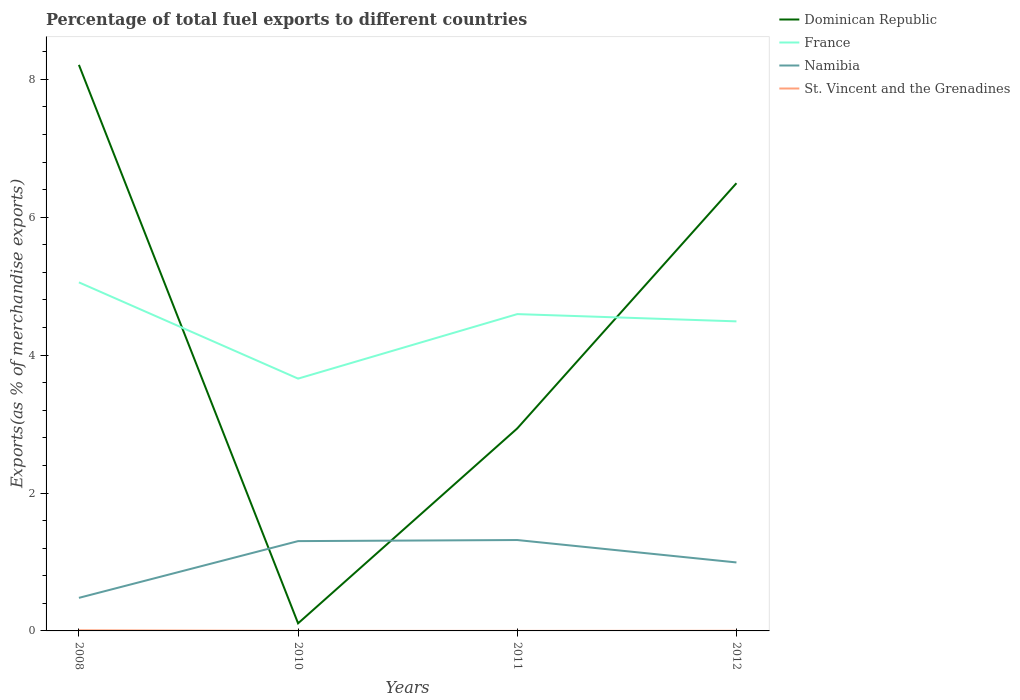Does the line corresponding to France intersect with the line corresponding to Dominican Republic?
Provide a succinct answer. Yes. Is the number of lines equal to the number of legend labels?
Your answer should be very brief. Yes. Across all years, what is the maximum percentage of exports to different countries in St. Vincent and the Grenadines?
Your answer should be very brief. 0. In which year was the percentage of exports to different countries in St. Vincent and the Grenadines maximum?
Offer a terse response. 2011. What is the total percentage of exports to different countries in St. Vincent and the Grenadines in the graph?
Offer a terse response. 0.01. What is the difference between the highest and the second highest percentage of exports to different countries in Namibia?
Give a very brief answer. 0.84. What is the difference between the highest and the lowest percentage of exports to different countries in Dominican Republic?
Your response must be concise. 2. How many lines are there?
Provide a succinct answer. 4. What is the difference between two consecutive major ticks on the Y-axis?
Your answer should be very brief. 2. Does the graph contain any zero values?
Provide a short and direct response. No. How many legend labels are there?
Give a very brief answer. 4. How are the legend labels stacked?
Provide a short and direct response. Vertical. What is the title of the graph?
Ensure brevity in your answer.  Percentage of total fuel exports to different countries. What is the label or title of the X-axis?
Keep it short and to the point. Years. What is the label or title of the Y-axis?
Make the answer very short. Exports(as % of merchandise exports). What is the Exports(as % of merchandise exports) of Dominican Republic in 2008?
Make the answer very short. 8.21. What is the Exports(as % of merchandise exports) in France in 2008?
Make the answer very short. 5.05. What is the Exports(as % of merchandise exports) in Namibia in 2008?
Your response must be concise. 0.48. What is the Exports(as % of merchandise exports) of St. Vincent and the Grenadines in 2008?
Make the answer very short. 0.01. What is the Exports(as % of merchandise exports) of Dominican Republic in 2010?
Your response must be concise. 0.11. What is the Exports(as % of merchandise exports) in France in 2010?
Offer a very short reply. 3.66. What is the Exports(as % of merchandise exports) in Namibia in 2010?
Make the answer very short. 1.3. What is the Exports(as % of merchandise exports) of St. Vincent and the Grenadines in 2010?
Give a very brief answer. 0. What is the Exports(as % of merchandise exports) of Dominican Republic in 2011?
Give a very brief answer. 2.94. What is the Exports(as % of merchandise exports) of France in 2011?
Provide a succinct answer. 4.59. What is the Exports(as % of merchandise exports) in Namibia in 2011?
Offer a terse response. 1.32. What is the Exports(as % of merchandise exports) of St. Vincent and the Grenadines in 2011?
Ensure brevity in your answer.  0. What is the Exports(as % of merchandise exports) of Dominican Republic in 2012?
Keep it short and to the point. 6.49. What is the Exports(as % of merchandise exports) of France in 2012?
Offer a very short reply. 4.49. What is the Exports(as % of merchandise exports) of Namibia in 2012?
Make the answer very short. 0.99. What is the Exports(as % of merchandise exports) in St. Vincent and the Grenadines in 2012?
Your answer should be compact. 0. Across all years, what is the maximum Exports(as % of merchandise exports) of Dominican Republic?
Offer a very short reply. 8.21. Across all years, what is the maximum Exports(as % of merchandise exports) in France?
Your response must be concise. 5.05. Across all years, what is the maximum Exports(as % of merchandise exports) in Namibia?
Provide a succinct answer. 1.32. Across all years, what is the maximum Exports(as % of merchandise exports) of St. Vincent and the Grenadines?
Your response must be concise. 0.01. Across all years, what is the minimum Exports(as % of merchandise exports) in Dominican Republic?
Your response must be concise. 0.11. Across all years, what is the minimum Exports(as % of merchandise exports) of France?
Your response must be concise. 3.66. Across all years, what is the minimum Exports(as % of merchandise exports) of Namibia?
Your answer should be compact. 0.48. Across all years, what is the minimum Exports(as % of merchandise exports) of St. Vincent and the Grenadines?
Your answer should be compact. 0. What is the total Exports(as % of merchandise exports) in Dominican Republic in the graph?
Ensure brevity in your answer.  17.75. What is the total Exports(as % of merchandise exports) of France in the graph?
Provide a short and direct response. 17.8. What is the total Exports(as % of merchandise exports) in Namibia in the graph?
Make the answer very short. 4.09. What is the total Exports(as % of merchandise exports) in St. Vincent and the Grenadines in the graph?
Provide a short and direct response. 0.01. What is the difference between the Exports(as % of merchandise exports) in Dominican Republic in 2008 and that in 2010?
Make the answer very short. 8.1. What is the difference between the Exports(as % of merchandise exports) in France in 2008 and that in 2010?
Give a very brief answer. 1.4. What is the difference between the Exports(as % of merchandise exports) of Namibia in 2008 and that in 2010?
Keep it short and to the point. -0.82. What is the difference between the Exports(as % of merchandise exports) in St. Vincent and the Grenadines in 2008 and that in 2010?
Ensure brevity in your answer.  0.01. What is the difference between the Exports(as % of merchandise exports) of Dominican Republic in 2008 and that in 2011?
Your answer should be compact. 5.27. What is the difference between the Exports(as % of merchandise exports) in France in 2008 and that in 2011?
Ensure brevity in your answer.  0.46. What is the difference between the Exports(as % of merchandise exports) in Namibia in 2008 and that in 2011?
Your answer should be compact. -0.84. What is the difference between the Exports(as % of merchandise exports) of St. Vincent and the Grenadines in 2008 and that in 2011?
Provide a succinct answer. 0.01. What is the difference between the Exports(as % of merchandise exports) of Dominican Republic in 2008 and that in 2012?
Your answer should be compact. 1.72. What is the difference between the Exports(as % of merchandise exports) in France in 2008 and that in 2012?
Ensure brevity in your answer.  0.57. What is the difference between the Exports(as % of merchandise exports) of Namibia in 2008 and that in 2012?
Give a very brief answer. -0.51. What is the difference between the Exports(as % of merchandise exports) of St. Vincent and the Grenadines in 2008 and that in 2012?
Provide a short and direct response. 0.01. What is the difference between the Exports(as % of merchandise exports) of Dominican Republic in 2010 and that in 2011?
Make the answer very short. -2.83. What is the difference between the Exports(as % of merchandise exports) in France in 2010 and that in 2011?
Make the answer very short. -0.94. What is the difference between the Exports(as % of merchandise exports) of Namibia in 2010 and that in 2011?
Keep it short and to the point. -0.02. What is the difference between the Exports(as % of merchandise exports) of St. Vincent and the Grenadines in 2010 and that in 2011?
Give a very brief answer. 0. What is the difference between the Exports(as % of merchandise exports) in Dominican Republic in 2010 and that in 2012?
Offer a very short reply. -6.38. What is the difference between the Exports(as % of merchandise exports) in France in 2010 and that in 2012?
Your response must be concise. -0.83. What is the difference between the Exports(as % of merchandise exports) in Namibia in 2010 and that in 2012?
Your answer should be compact. 0.31. What is the difference between the Exports(as % of merchandise exports) in St. Vincent and the Grenadines in 2010 and that in 2012?
Give a very brief answer. -0. What is the difference between the Exports(as % of merchandise exports) of Dominican Republic in 2011 and that in 2012?
Your answer should be compact. -3.56. What is the difference between the Exports(as % of merchandise exports) in France in 2011 and that in 2012?
Provide a short and direct response. 0.11. What is the difference between the Exports(as % of merchandise exports) of Namibia in 2011 and that in 2012?
Keep it short and to the point. 0.33. What is the difference between the Exports(as % of merchandise exports) in St. Vincent and the Grenadines in 2011 and that in 2012?
Your answer should be very brief. -0. What is the difference between the Exports(as % of merchandise exports) of Dominican Republic in 2008 and the Exports(as % of merchandise exports) of France in 2010?
Make the answer very short. 4.55. What is the difference between the Exports(as % of merchandise exports) of Dominican Republic in 2008 and the Exports(as % of merchandise exports) of Namibia in 2010?
Keep it short and to the point. 6.91. What is the difference between the Exports(as % of merchandise exports) in Dominican Republic in 2008 and the Exports(as % of merchandise exports) in St. Vincent and the Grenadines in 2010?
Offer a very short reply. 8.21. What is the difference between the Exports(as % of merchandise exports) in France in 2008 and the Exports(as % of merchandise exports) in Namibia in 2010?
Your answer should be very brief. 3.75. What is the difference between the Exports(as % of merchandise exports) of France in 2008 and the Exports(as % of merchandise exports) of St. Vincent and the Grenadines in 2010?
Give a very brief answer. 5.05. What is the difference between the Exports(as % of merchandise exports) in Namibia in 2008 and the Exports(as % of merchandise exports) in St. Vincent and the Grenadines in 2010?
Keep it short and to the point. 0.48. What is the difference between the Exports(as % of merchandise exports) of Dominican Republic in 2008 and the Exports(as % of merchandise exports) of France in 2011?
Offer a terse response. 3.61. What is the difference between the Exports(as % of merchandise exports) in Dominican Republic in 2008 and the Exports(as % of merchandise exports) in Namibia in 2011?
Offer a very short reply. 6.89. What is the difference between the Exports(as % of merchandise exports) of Dominican Republic in 2008 and the Exports(as % of merchandise exports) of St. Vincent and the Grenadines in 2011?
Give a very brief answer. 8.21. What is the difference between the Exports(as % of merchandise exports) of France in 2008 and the Exports(as % of merchandise exports) of Namibia in 2011?
Provide a succinct answer. 3.74. What is the difference between the Exports(as % of merchandise exports) of France in 2008 and the Exports(as % of merchandise exports) of St. Vincent and the Grenadines in 2011?
Offer a very short reply. 5.05. What is the difference between the Exports(as % of merchandise exports) in Namibia in 2008 and the Exports(as % of merchandise exports) in St. Vincent and the Grenadines in 2011?
Offer a terse response. 0.48. What is the difference between the Exports(as % of merchandise exports) of Dominican Republic in 2008 and the Exports(as % of merchandise exports) of France in 2012?
Your response must be concise. 3.72. What is the difference between the Exports(as % of merchandise exports) in Dominican Republic in 2008 and the Exports(as % of merchandise exports) in Namibia in 2012?
Give a very brief answer. 7.22. What is the difference between the Exports(as % of merchandise exports) in Dominican Republic in 2008 and the Exports(as % of merchandise exports) in St. Vincent and the Grenadines in 2012?
Make the answer very short. 8.21. What is the difference between the Exports(as % of merchandise exports) of France in 2008 and the Exports(as % of merchandise exports) of Namibia in 2012?
Ensure brevity in your answer.  4.06. What is the difference between the Exports(as % of merchandise exports) of France in 2008 and the Exports(as % of merchandise exports) of St. Vincent and the Grenadines in 2012?
Offer a terse response. 5.05. What is the difference between the Exports(as % of merchandise exports) of Namibia in 2008 and the Exports(as % of merchandise exports) of St. Vincent and the Grenadines in 2012?
Provide a succinct answer. 0.48. What is the difference between the Exports(as % of merchandise exports) in Dominican Republic in 2010 and the Exports(as % of merchandise exports) in France in 2011?
Ensure brevity in your answer.  -4.48. What is the difference between the Exports(as % of merchandise exports) of Dominican Republic in 2010 and the Exports(as % of merchandise exports) of Namibia in 2011?
Ensure brevity in your answer.  -1.21. What is the difference between the Exports(as % of merchandise exports) of Dominican Republic in 2010 and the Exports(as % of merchandise exports) of St. Vincent and the Grenadines in 2011?
Offer a very short reply. 0.11. What is the difference between the Exports(as % of merchandise exports) of France in 2010 and the Exports(as % of merchandise exports) of Namibia in 2011?
Make the answer very short. 2.34. What is the difference between the Exports(as % of merchandise exports) of France in 2010 and the Exports(as % of merchandise exports) of St. Vincent and the Grenadines in 2011?
Keep it short and to the point. 3.66. What is the difference between the Exports(as % of merchandise exports) in Namibia in 2010 and the Exports(as % of merchandise exports) in St. Vincent and the Grenadines in 2011?
Offer a terse response. 1.3. What is the difference between the Exports(as % of merchandise exports) of Dominican Republic in 2010 and the Exports(as % of merchandise exports) of France in 2012?
Offer a very short reply. -4.38. What is the difference between the Exports(as % of merchandise exports) in Dominican Republic in 2010 and the Exports(as % of merchandise exports) in Namibia in 2012?
Ensure brevity in your answer.  -0.88. What is the difference between the Exports(as % of merchandise exports) of Dominican Republic in 2010 and the Exports(as % of merchandise exports) of St. Vincent and the Grenadines in 2012?
Your response must be concise. 0.11. What is the difference between the Exports(as % of merchandise exports) in France in 2010 and the Exports(as % of merchandise exports) in Namibia in 2012?
Your response must be concise. 2.67. What is the difference between the Exports(as % of merchandise exports) in France in 2010 and the Exports(as % of merchandise exports) in St. Vincent and the Grenadines in 2012?
Provide a succinct answer. 3.66. What is the difference between the Exports(as % of merchandise exports) in Namibia in 2010 and the Exports(as % of merchandise exports) in St. Vincent and the Grenadines in 2012?
Keep it short and to the point. 1.3. What is the difference between the Exports(as % of merchandise exports) in Dominican Republic in 2011 and the Exports(as % of merchandise exports) in France in 2012?
Offer a very short reply. -1.55. What is the difference between the Exports(as % of merchandise exports) in Dominican Republic in 2011 and the Exports(as % of merchandise exports) in Namibia in 2012?
Make the answer very short. 1.94. What is the difference between the Exports(as % of merchandise exports) in Dominican Republic in 2011 and the Exports(as % of merchandise exports) in St. Vincent and the Grenadines in 2012?
Provide a short and direct response. 2.93. What is the difference between the Exports(as % of merchandise exports) of France in 2011 and the Exports(as % of merchandise exports) of Namibia in 2012?
Offer a very short reply. 3.6. What is the difference between the Exports(as % of merchandise exports) in France in 2011 and the Exports(as % of merchandise exports) in St. Vincent and the Grenadines in 2012?
Offer a very short reply. 4.59. What is the difference between the Exports(as % of merchandise exports) of Namibia in 2011 and the Exports(as % of merchandise exports) of St. Vincent and the Grenadines in 2012?
Your response must be concise. 1.32. What is the average Exports(as % of merchandise exports) in Dominican Republic per year?
Provide a short and direct response. 4.44. What is the average Exports(as % of merchandise exports) in France per year?
Your answer should be very brief. 4.45. What is the average Exports(as % of merchandise exports) in Namibia per year?
Provide a succinct answer. 1.02. What is the average Exports(as % of merchandise exports) in St. Vincent and the Grenadines per year?
Offer a terse response. 0. In the year 2008, what is the difference between the Exports(as % of merchandise exports) of Dominican Republic and Exports(as % of merchandise exports) of France?
Provide a succinct answer. 3.15. In the year 2008, what is the difference between the Exports(as % of merchandise exports) of Dominican Republic and Exports(as % of merchandise exports) of Namibia?
Your answer should be compact. 7.73. In the year 2008, what is the difference between the Exports(as % of merchandise exports) of Dominican Republic and Exports(as % of merchandise exports) of St. Vincent and the Grenadines?
Provide a succinct answer. 8.2. In the year 2008, what is the difference between the Exports(as % of merchandise exports) of France and Exports(as % of merchandise exports) of Namibia?
Give a very brief answer. 4.58. In the year 2008, what is the difference between the Exports(as % of merchandise exports) of France and Exports(as % of merchandise exports) of St. Vincent and the Grenadines?
Offer a very short reply. 5.05. In the year 2008, what is the difference between the Exports(as % of merchandise exports) of Namibia and Exports(as % of merchandise exports) of St. Vincent and the Grenadines?
Provide a succinct answer. 0.47. In the year 2010, what is the difference between the Exports(as % of merchandise exports) in Dominican Republic and Exports(as % of merchandise exports) in France?
Provide a short and direct response. -3.55. In the year 2010, what is the difference between the Exports(as % of merchandise exports) in Dominican Republic and Exports(as % of merchandise exports) in Namibia?
Offer a terse response. -1.19. In the year 2010, what is the difference between the Exports(as % of merchandise exports) of Dominican Republic and Exports(as % of merchandise exports) of St. Vincent and the Grenadines?
Ensure brevity in your answer.  0.11. In the year 2010, what is the difference between the Exports(as % of merchandise exports) in France and Exports(as % of merchandise exports) in Namibia?
Offer a very short reply. 2.36. In the year 2010, what is the difference between the Exports(as % of merchandise exports) of France and Exports(as % of merchandise exports) of St. Vincent and the Grenadines?
Give a very brief answer. 3.66. In the year 2010, what is the difference between the Exports(as % of merchandise exports) of Namibia and Exports(as % of merchandise exports) of St. Vincent and the Grenadines?
Give a very brief answer. 1.3. In the year 2011, what is the difference between the Exports(as % of merchandise exports) in Dominican Republic and Exports(as % of merchandise exports) in France?
Offer a terse response. -1.66. In the year 2011, what is the difference between the Exports(as % of merchandise exports) of Dominican Republic and Exports(as % of merchandise exports) of Namibia?
Your answer should be compact. 1.62. In the year 2011, what is the difference between the Exports(as % of merchandise exports) of Dominican Republic and Exports(as % of merchandise exports) of St. Vincent and the Grenadines?
Your response must be concise. 2.94. In the year 2011, what is the difference between the Exports(as % of merchandise exports) of France and Exports(as % of merchandise exports) of Namibia?
Provide a short and direct response. 3.28. In the year 2011, what is the difference between the Exports(as % of merchandise exports) of France and Exports(as % of merchandise exports) of St. Vincent and the Grenadines?
Provide a succinct answer. 4.59. In the year 2011, what is the difference between the Exports(as % of merchandise exports) of Namibia and Exports(as % of merchandise exports) of St. Vincent and the Grenadines?
Your answer should be compact. 1.32. In the year 2012, what is the difference between the Exports(as % of merchandise exports) in Dominican Republic and Exports(as % of merchandise exports) in France?
Your response must be concise. 2. In the year 2012, what is the difference between the Exports(as % of merchandise exports) in Dominican Republic and Exports(as % of merchandise exports) in Namibia?
Offer a terse response. 5.5. In the year 2012, what is the difference between the Exports(as % of merchandise exports) of Dominican Republic and Exports(as % of merchandise exports) of St. Vincent and the Grenadines?
Provide a succinct answer. 6.49. In the year 2012, what is the difference between the Exports(as % of merchandise exports) in France and Exports(as % of merchandise exports) in Namibia?
Make the answer very short. 3.5. In the year 2012, what is the difference between the Exports(as % of merchandise exports) of France and Exports(as % of merchandise exports) of St. Vincent and the Grenadines?
Offer a very short reply. 4.49. In the year 2012, what is the difference between the Exports(as % of merchandise exports) in Namibia and Exports(as % of merchandise exports) in St. Vincent and the Grenadines?
Keep it short and to the point. 0.99. What is the ratio of the Exports(as % of merchandise exports) in Dominican Republic in 2008 to that in 2010?
Give a very brief answer. 74.62. What is the ratio of the Exports(as % of merchandise exports) in France in 2008 to that in 2010?
Offer a terse response. 1.38. What is the ratio of the Exports(as % of merchandise exports) of Namibia in 2008 to that in 2010?
Give a very brief answer. 0.37. What is the ratio of the Exports(as % of merchandise exports) of St. Vincent and the Grenadines in 2008 to that in 2010?
Provide a short and direct response. 9.34. What is the ratio of the Exports(as % of merchandise exports) in Dominican Republic in 2008 to that in 2011?
Provide a succinct answer. 2.79. What is the ratio of the Exports(as % of merchandise exports) of France in 2008 to that in 2011?
Keep it short and to the point. 1.1. What is the ratio of the Exports(as % of merchandise exports) in Namibia in 2008 to that in 2011?
Your answer should be very brief. 0.36. What is the ratio of the Exports(as % of merchandise exports) of St. Vincent and the Grenadines in 2008 to that in 2011?
Ensure brevity in your answer.  22.86. What is the ratio of the Exports(as % of merchandise exports) of Dominican Republic in 2008 to that in 2012?
Your response must be concise. 1.26. What is the ratio of the Exports(as % of merchandise exports) in France in 2008 to that in 2012?
Offer a terse response. 1.13. What is the ratio of the Exports(as % of merchandise exports) of Namibia in 2008 to that in 2012?
Make the answer very short. 0.48. What is the ratio of the Exports(as % of merchandise exports) of St. Vincent and the Grenadines in 2008 to that in 2012?
Your answer should be compact. 4.32. What is the ratio of the Exports(as % of merchandise exports) in Dominican Republic in 2010 to that in 2011?
Your answer should be very brief. 0.04. What is the ratio of the Exports(as % of merchandise exports) of France in 2010 to that in 2011?
Provide a short and direct response. 0.8. What is the ratio of the Exports(as % of merchandise exports) of St. Vincent and the Grenadines in 2010 to that in 2011?
Your answer should be compact. 2.45. What is the ratio of the Exports(as % of merchandise exports) of Dominican Republic in 2010 to that in 2012?
Give a very brief answer. 0.02. What is the ratio of the Exports(as % of merchandise exports) of France in 2010 to that in 2012?
Your answer should be compact. 0.82. What is the ratio of the Exports(as % of merchandise exports) of Namibia in 2010 to that in 2012?
Make the answer very short. 1.31. What is the ratio of the Exports(as % of merchandise exports) in St. Vincent and the Grenadines in 2010 to that in 2012?
Offer a terse response. 0.46. What is the ratio of the Exports(as % of merchandise exports) of Dominican Republic in 2011 to that in 2012?
Your answer should be compact. 0.45. What is the ratio of the Exports(as % of merchandise exports) in France in 2011 to that in 2012?
Your answer should be very brief. 1.02. What is the ratio of the Exports(as % of merchandise exports) in Namibia in 2011 to that in 2012?
Offer a terse response. 1.33. What is the ratio of the Exports(as % of merchandise exports) in St. Vincent and the Grenadines in 2011 to that in 2012?
Ensure brevity in your answer.  0.19. What is the difference between the highest and the second highest Exports(as % of merchandise exports) of Dominican Republic?
Give a very brief answer. 1.72. What is the difference between the highest and the second highest Exports(as % of merchandise exports) of France?
Give a very brief answer. 0.46. What is the difference between the highest and the second highest Exports(as % of merchandise exports) in Namibia?
Your answer should be compact. 0.02. What is the difference between the highest and the second highest Exports(as % of merchandise exports) of St. Vincent and the Grenadines?
Provide a short and direct response. 0.01. What is the difference between the highest and the lowest Exports(as % of merchandise exports) in Dominican Republic?
Ensure brevity in your answer.  8.1. What is the difference between the highest and the lowest Exports(as % of merchandise exports) of France?
Offer a very short reply. 1.4. What is the difference between the highest and the lowest Exports(as % of merchandise exports) in Namibia?
Ensure brevity in your answer.  0.84. What is the difference between the highest and the lowest Exports(as % of merchandise exports) of St. Vincent and the Grenadines?
Your answer should be compact. 0.01. 